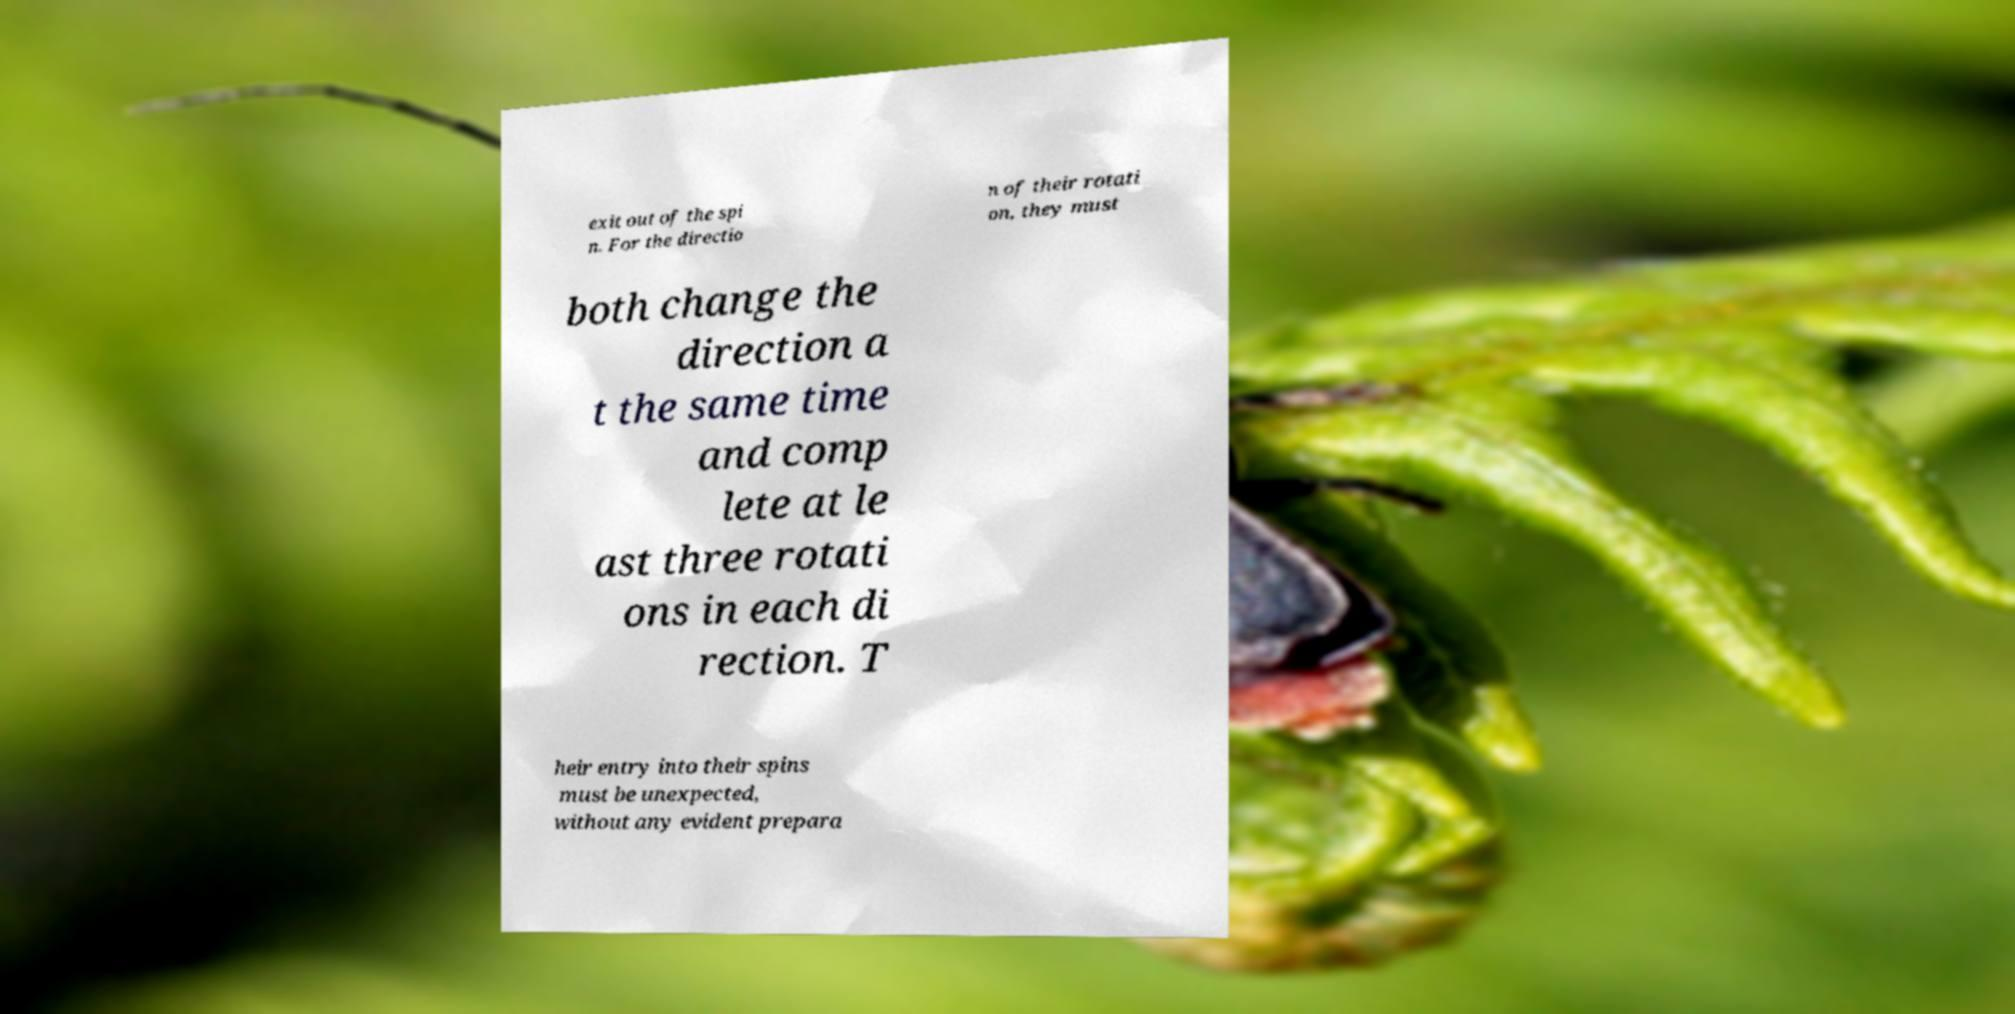There's text embedded in this image that I need extracted. Can you transcribe it verbatim? exit out of the spi n. For the directio n of their rotati on, they must both change the direction a t the same time and comp lete at le ast three rotati ons in each di rection. T heir entry into their spins must be unexpected, without any evident prepara 